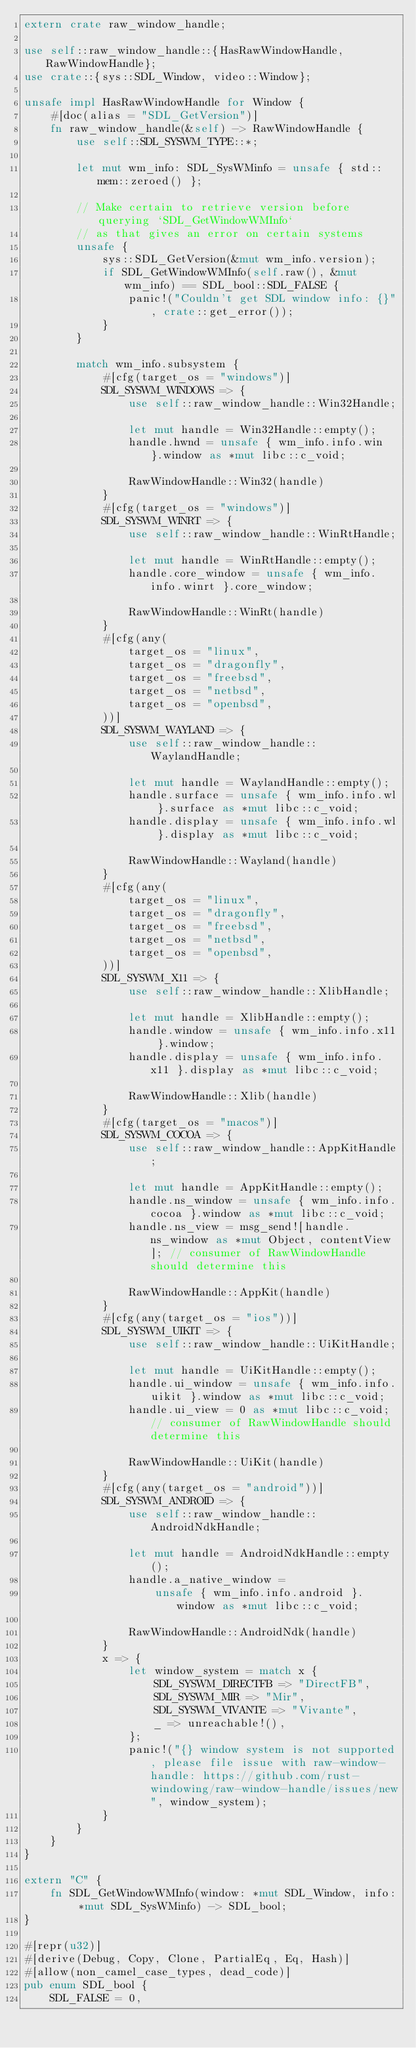Convert code to text. <code><loc_0><loc_0><loc_500><loc_500><_Rust_>extern crate raw_window_handle;

use self::raw_window_handle::{HasRawWindowHandle, RawWindowHandle};
use crate::{sys::SDL_Window, video::Window};

unsafe impl HasRawWindowHandle for Window {
    #[doc(alias = "SDL_GetVersion")]
    fn raw_window_handle(&self) -> RawWindowHandle {
        use self::SDL_SYSWM_TYPE::*;

        let mut wm_info: SDL_SysWMinfo = unsafe { std::mem::zeroed() };

        // Make certain to retrieve version before querying `SDL_GetWindowWMInfo`
        // as that gives an error on certain systems
        unsafe {
            sys::SDL_GetVersion(&mut wm_info.version);
            if SDL_GetWindowWMInfo(self.raw(), &mut wm_info) == SDL_bool::SDL_FALSE {
                panic!("Couldn't get SDL window info: {}", crate::get_error());
            }
        }

        match wm_info.subsystem {
            #[cfg(target_os = "windows")]
            SDL_SYSWM_WINDOWS => {
                use self::raw_window_handle::Win32Handle;

                let mut handle = Win32Handle::empty();
                handle.hwnd = unsafe { wm_info.info.win }.window as *mut libc::c_void;

                RawWindowHandle::Win32(handle)
            }
            #[cfg(target_os = "windows")]
            SDL_SYSWM_WINRT => {
                use self::raw_window_handle::WinRtHandle;

                let mut handle = WinRtHandle::empty();
                handle.core_window = unsafe { wm_info.info.winrt }.core_window;

                RawWindowHandle::WinRt(handle)
            }
            #[cfg(any(
                target_os = "linux",
                target_os = "dragonfly",
                target_os = "freebsd",
                target_os = "netbsd",
                target_os = "openbsd",
            ))]
            SDL_SYSWM_WAYLAND => {
                use self::raw_window_handle::WaylandHandle;

                let mut handle = WaylandHandle::empty();
                handle.surface = unsafe { wm_info.info.wl }.surface as *mut libc::c_void;
                handle.display = unsafe { wm_info.info.wl }.display as *mut libc::c_void;

                RawWindowHandle::Wayland(handle)
            }
            #[cfg(any(
                target_os = "linux",
                target_os = "dragonfly",
                target_os = "freebsd",
                target_os = "netbsd",
                target_os = "openbsd",
            ))]
            SDL_SYSWM_X11 => {
                use self::raw_window_handle::XlibHandle;

                let mut handle = XlibHandle::empty();
                handle.window = unsafe { wm_info.info.x11 }.window;
                handle.display = unsafe { wm_info.info.x11 }.display as *mut libc::c_void;

                RawWindowHandle::Xlib(handle)
            }
            #[cfg(target_os = "macos")]
            SDL_SYSWM_COCOA => {
                use self::raw_window_handle::AppKitHandle;

                let mut handle = AppKitHandle::empty();
                handle.ns_window = unsafe { wm_info.info.cocoa }.window as *mut libc::c_void;
                handle.ns_view = msg_send![handle.ns_window as *mut Object, contentView]; // consumer of RawWindowHandle should determine this

                RawWindowHandle::AppKit(handle)
            }
            #[cfg(any(target_os = "ios"))]
            SDL_SYSWM_UIKIT => {
                use self::raw_window_handle::UiKitHandle;

                let mut handle = UiKitHandle::empty();
                handle.ui_window = unsafe { wm_info.info.uikit }.window as *mut libc::c_void;
                handle.ui_view = 0 as *mut libc::c_void; // consumer of RawWindowHandle should determine this

                RawWindowHandle::UiKit(handle)
            }
            #[cfg(any(target_os = "android"))]
            SDL_SYSWM_ANDROID => {
                use self::raw_window_handle::AndroidNdkHandle;

                let mut handle = AndroidNdkHandle::empty();
                handle.a_native_window =
                    unsafe { wm_info.info.android }.window as *mut libc::c_void;

                RawWindowHandle::AndroidNdk(handle)
            }
            x => {
                let window_system = match x {
                    SDL_SYSWM_DIRECTFB => "DirectFB",
                    SDL_SYSWM_MIR => "Mir",
                    SDL_SYSWM_VIVANTE => "Vivante",
                    _ => unreachable!(),
                };
                panic!("{} window system is not supported, please file issue with raw-window-handle: https://github.com/rust-windowing/raw-window-handle/issues/new", window_system);
            }
        }
    }
}

extern "C" {
    fn SDL_GetWindowWMInfo(window: *mut SDL_Window, info: *mut SDL_SysWMinfo) -> SDL_bool;
}

#[repr(u32)]
#[derive(Debug, Copy, Clone, PartialEq, Eq, Hash)]
#[allow(non_camel_case_types, dead_code)]
pub enum SDL_bool {
    SDL_FALSE = 0,</code> 